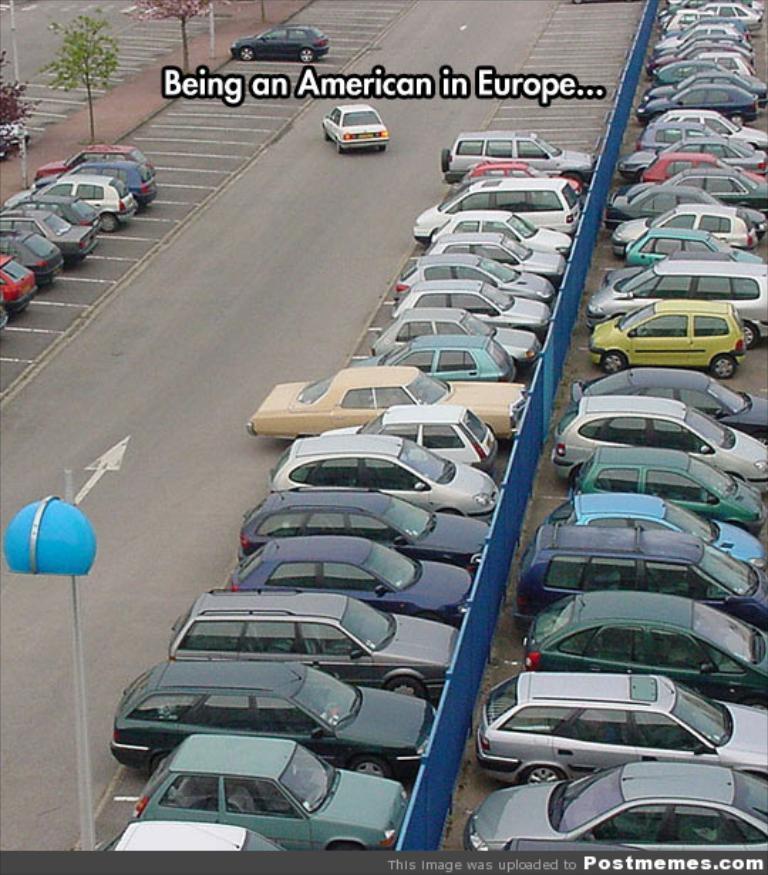How would you summarize this image in a sentence or two? In this image we can see cars on the road. There are plants. There is some text. At the bottom of the image there is a pole. 